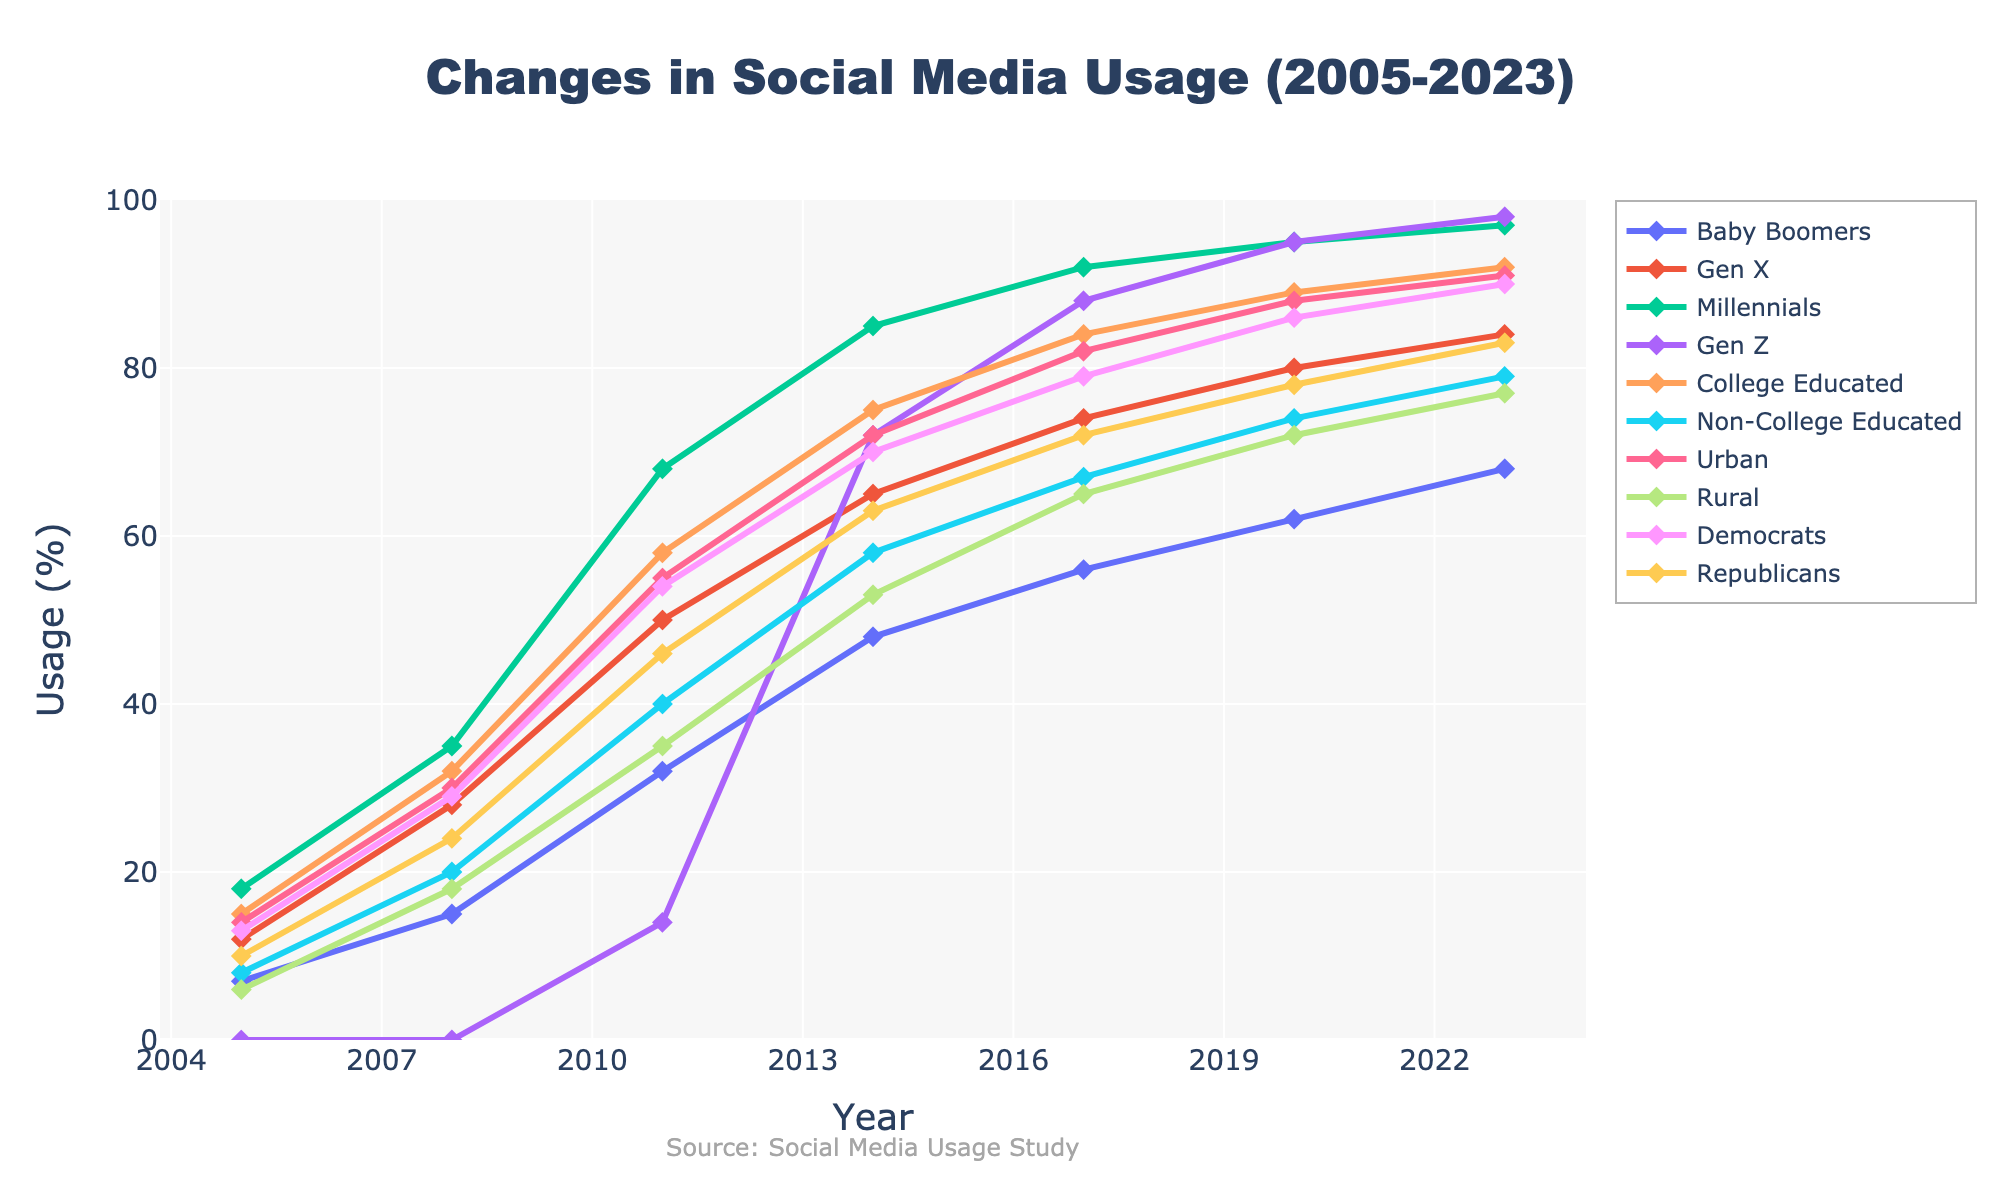what's the difference in social media usage between Millennials and Gen Z in 2008? To find the difference in social media usage between Millennials and Gen Z in 2008, look at the respective values for each demographic group in that year. For Millennials, the usage is 35%, and for Gen Z, it's 0%. Subtract the smaller value from the larger one: 35% - 0% = 35%.
Answer: 35% which demographic group showed the highest increase in social media usage from 2005 to 2023? To find the highest increase in social media usage, compare the difference in percentages from 2005 to 2023 for all demographic groups. Millennials go from 18% to 97%, an increase of 79%. Gen Z starts at 0% in 2005 and increases to 98% in 2023, a total increase of 98%. This is the largest increase among all groups.
Answer: Gen Z what's the average social media usage among College Educated individuals from 2005 to 2023? To find the average social media usage among College Educated individuals, sum the usage percentages from 2005, 2008, 2011, 2014, 2017, 2020, and 2023, then divide by the number of years. (15 + 32 + 58 + 75 + 84 + 89 + 92) / 7 = 63.57%.
Answer: 63.57% did Non-College Educated individuals or Urban residents have higher social media usage in 2017? To answer this, compare the usage percentages for Non-College Educated individuals (67%) and Urban residents (82%) in 2017. Urban residents have a higher usage.
Answer: Urban residents which type of area (Urban or Rural) has consistently higher social media usage from 2005 to 2023? To determine this, observe the trends for Urban and Rural areas over the years. Urban residents consistently show higher social media usage compared to Rural residents throughout the time span.
Answer: Urban what is the median social media usage percentage for Gen X across all the years? To find the median, list the usage percentages for Gen X across all years: 12%, 28%, 50%, 65%, 74%, 80%, 84%. The median is the middle value in this sorted list. So, the median value is 65%.
Answer: 65% by how much did social media usage among Baby Boomers increase from 2017 to 2023? To find the increase, subtract the 2017 percentage for Baby Boomers from the 2023 percentage. The usage was 56% in 2017 and 68% in 2023. Therefore, the increase is 68% - 56% = 12%.
Answer: 12% which political affiliation (Democrats or Republicans) had a larger percentage increase in social media usage from 2005 to 2023? To find this, compare the increase for Democrats (90% - 13% = 77%) and Republicans (83% - 10% = 73%). Democrats had a larger percentage increase.
Answer: Democrats describe the trend in social media usage among Gen Z from 2005 to 2023. To describe the trend, observe the usage percentages for Gen Z over the years. It starts from 0% in 2005, 0% in 2008, 14% in 2011, increases significantly to 72% in 2014, and continues to rise to 88% in 2017, 95% in 2020, and then 98% in 2023. This shows a rapidly increasing trend.
Answer: Rapidly increasing what's the difference between social media usage among Democrats and Republicans in 2023? To find the difference, subtract the Republicans' usage percentage from Democrats' in 2023. Democrats' usage is 90% and Republicans' usage is 83%. The difference is 90% - 83% = 7%.
Answer: 7% 